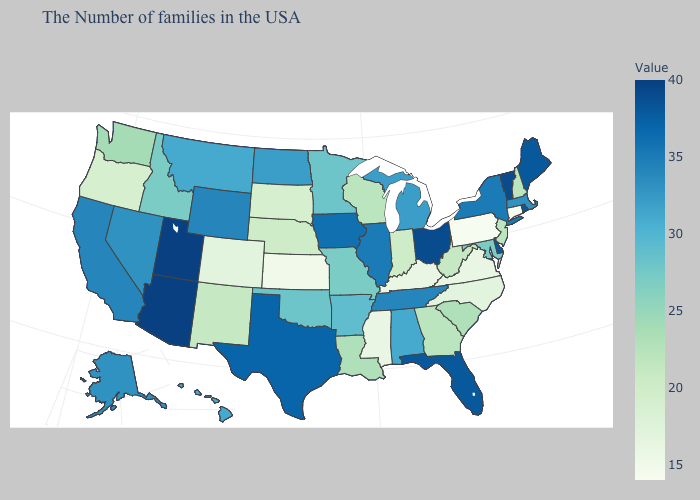Is the legend a continuous bar?
Give a very brief answer. Yes. Which states have the lowest value in the West?
Concise answer only. Colorado. Which states have the lowest value in the MidWest?
Keep it brief. Kansas. Does Connecticut have the lowest value in the USA?
Short answer required. Yes. Does Georgia have a higher value than Tennessee?
Answer briefly. No. Which states have the lowest value in the MidWest?
Answer briefly. Kansas. Among the states that border Illinois , which have the lowest value?
Give a very brief answer. Kentucky. 